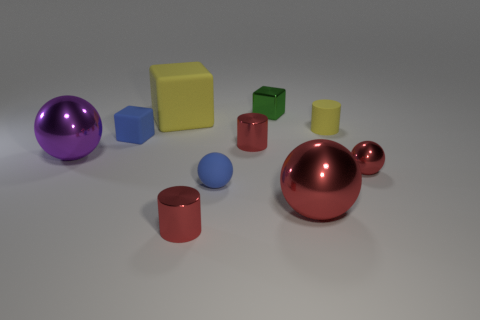Subtract all brown blocks. How many red spheres are left? 2 Subtract all tiny metallic balls. How many balls are left? 3 Subtract 2 spheres. How many spheres are left? 2 Subtract all blue spheres. How many spheres are left? 3 Subtract all brown balls. Subtract all purple blocks. How many balls are left? 4 Subtract all blocks. How many objects are left? 7 Subtract all red metallic things. Subtract all big purple shiny balls. How many objects are left? 5 Add 9 big red objects. How many big red objects are left? 10 Add 2 large shiny spheres. How many large shiny spheres exist? 4 Subtract 1 yellow cubes. How many objects are left? 9 